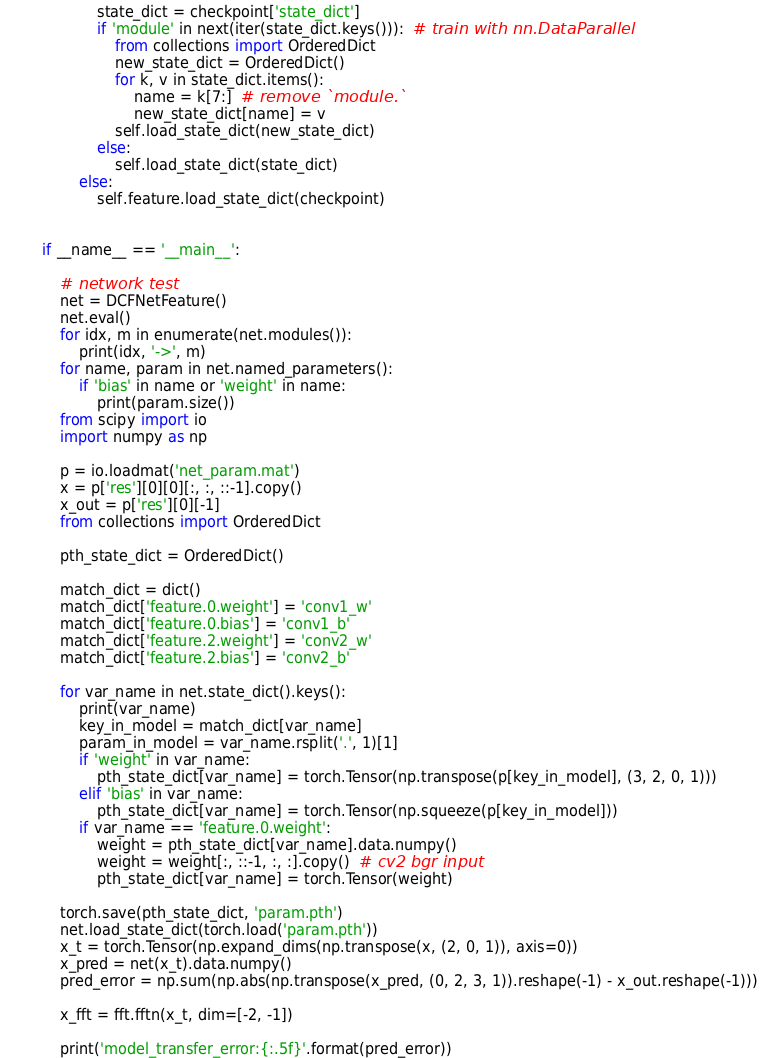Convert code to text. <code><loc_0><loc_0><loc_500><loc_500><_Python_>            state_dict = checkpoint['state_dict']
            if 'module' in next(iter(state_dict.keys())):  # train with nn.DataParallel
                from collections import OrderedDict
                new_state_dict = OrderedDict()
                for k, v in state_dict.items():
                    name = k[7:]  # remove `module.`
                    new_state_dict[name] = v
                self.load_state_dict(new_state_dict)
            else:
                self.load_state_dict(state_dict)
        else:
            self.feature.load_state_dict(checkpoint)


if __name__ == '__main__':

    # network test
    net = DCFNetFeature()
    net.eval()
    for idx, m in enumerate(net.modules()):
        print(idx, '->', m)
    for name, param in net.named_parameters():
        if 'bias' in name or 'weight' in name:
            print(param.size())
    from scipy import io
    import numpy as np

    p = io.loadmat('net_param.mat')
    x = p['res'][0][0][:, :, ::-1].copy()
    x_out = p['res'][0][-1]
    from collections import OrderedDict

    pth_state_dict = OrderedDict()

    match_dict = dict()
    match_dict['feature.0.weight'] = 'conv1_w'
    match_dict['feature.0.bias'] = 'conv1_b'
    match_dict['feature.2.weight'] = 'conv2_w'
    match_dict['feature.2.bias'] = 'conv2_b'

    for var_name in net.state_dict().keys():
        print(var_name)
        key_in_model = match_dict[var_name]
        param_in_model = var_name.rsplit('.', 1)[1]
        if 'weight' in var_name:
            pth_state_dict[var_name] = torch.Tensor(np.transpose(p[key_in_model], (3, 2, 0, 1)))
        elif 'bias' in var_name:
            pth_state_dict[var_name] = torch.Tensor(np.squeeze(p[key_in_model]))
        if var_name == 'feature.0.weight':
            weight = pth_state_dict[var_name].data.numpy()
            weight = weight[:, ::-1, :, :].copy()  # cv2 bgr input
            pth_state_dict[var_name] = torch.Tensor(weight)

    torch.save(pth_state_dict, 'param.pth')
    net.load_state_dict(torch.load('param.pth'))
    x_t = torch.Tensor(np.expand_dims(np.transpose(x, (2, 0, 1)), axis=0))
    x_pred = net(x_t).data.numpy()
    pred_error = np.sum(np.abs(np.transpose(x_pred, (0, 2, 3, 1)).reshape(-1) - x_out.reshape(-1)))

    x_fft = fft.fftn(x_t, dim=[-2, -1])

    print('model_transfer_error:{:.5f}'.format(pred_error))
</code> 